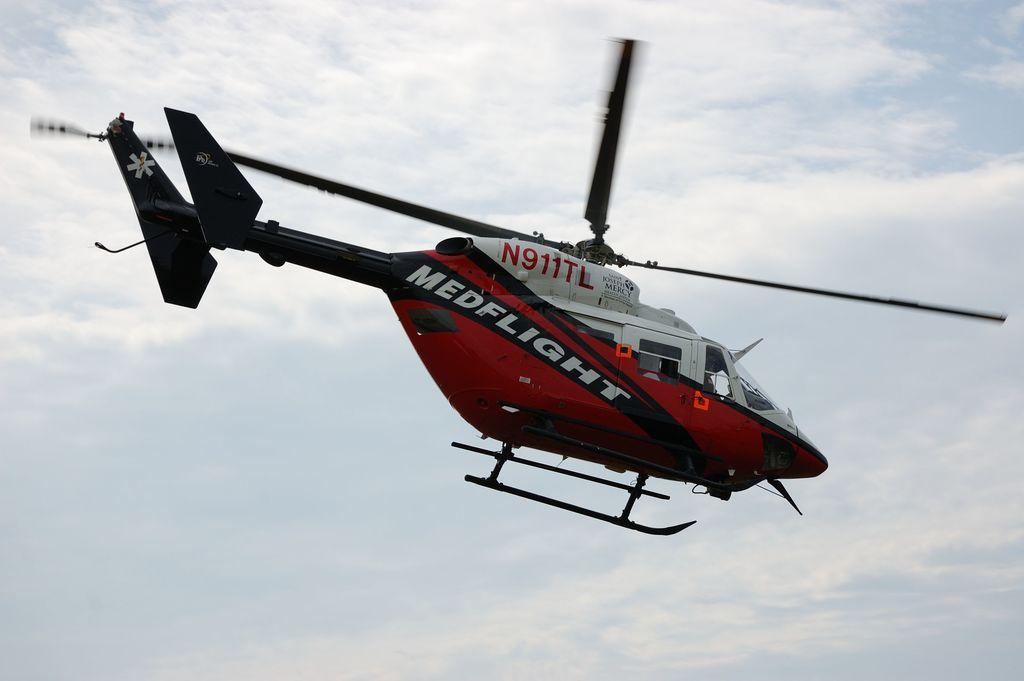<image>
Describe the image concisely. A medflight helicopter is in the air on a cloudy day. 